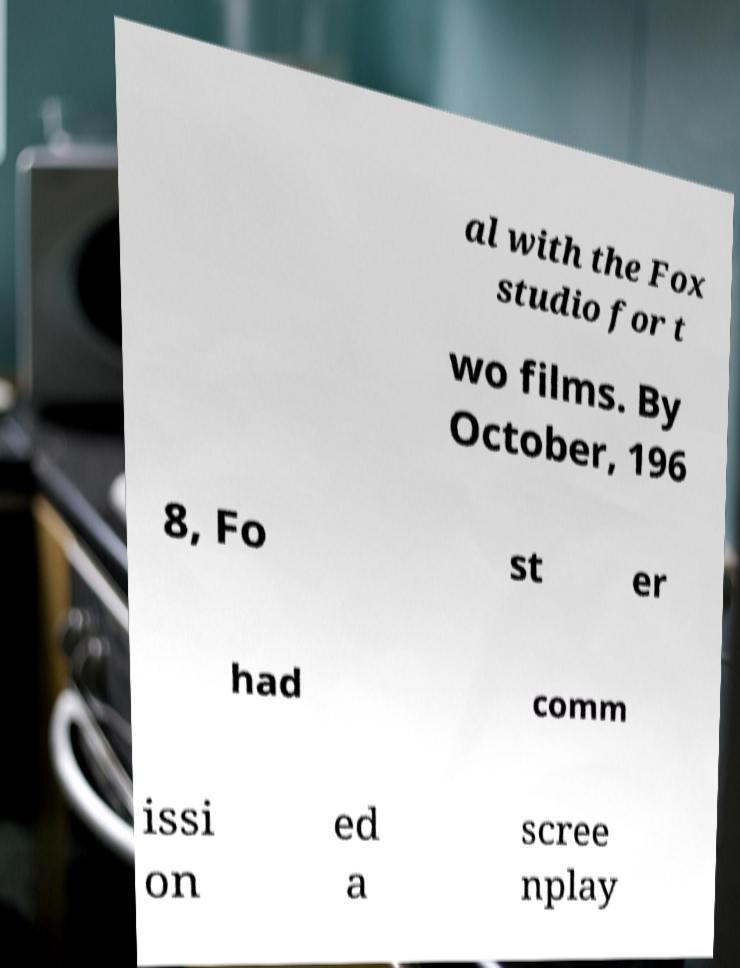Please read and relay the text visible in this image. What does it say? al with the Fox studio for t wo films. By October, 196 8, Fo st er had comm issi on ed a scree nplay 